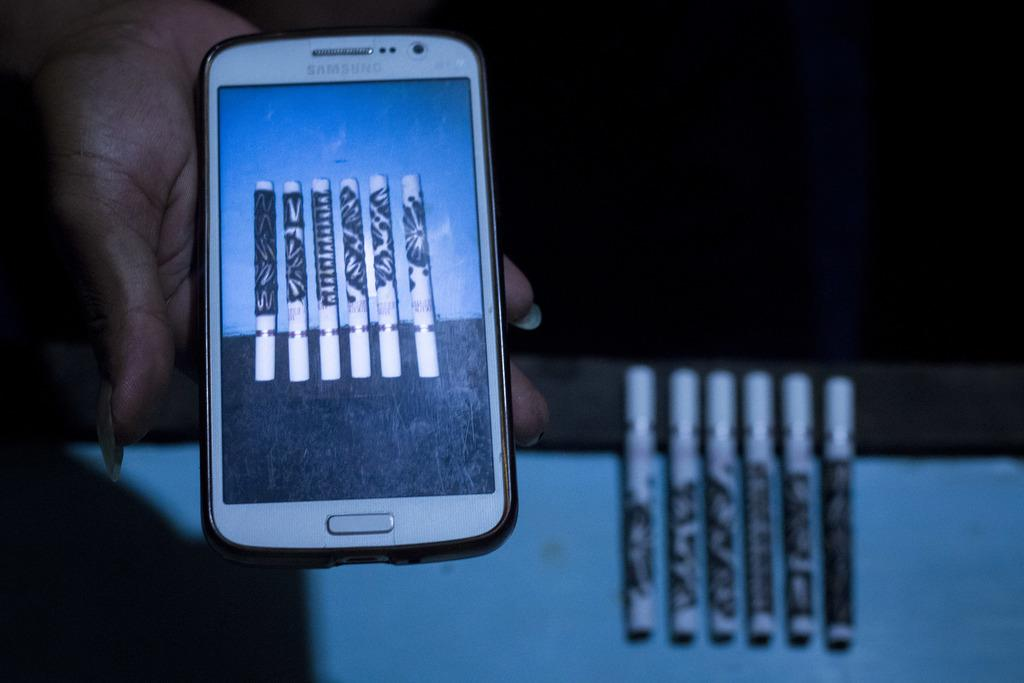<image>
Give a short and clear explanation of the subsequent image. a phone that says Samsung on the front of it 